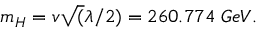Convert formula to latex. <formula><loc_0><loc_0><loc_500><loc_500>m _ { H } = v \sqrt { ( } \lambda / 2 ) = 2 6 0 . 7 7 4 \, G e V .</formula> 